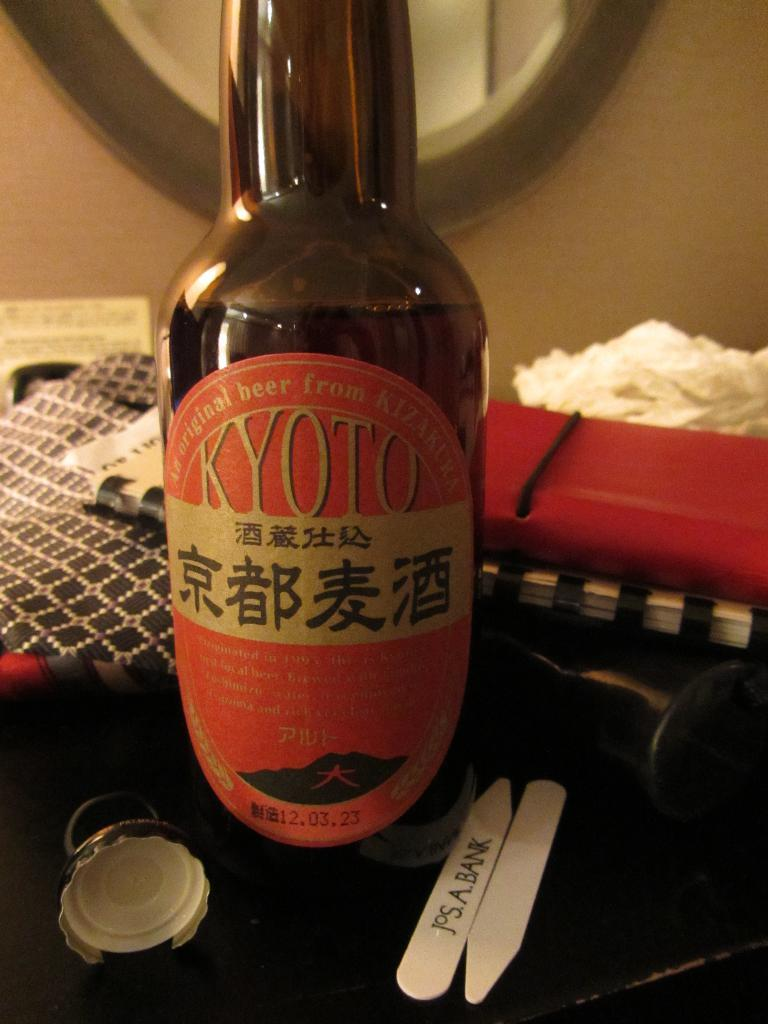<image>
Write a terse but informative summary of the picture. A bottle of Japanese beer that reads KYOTO on the front. 